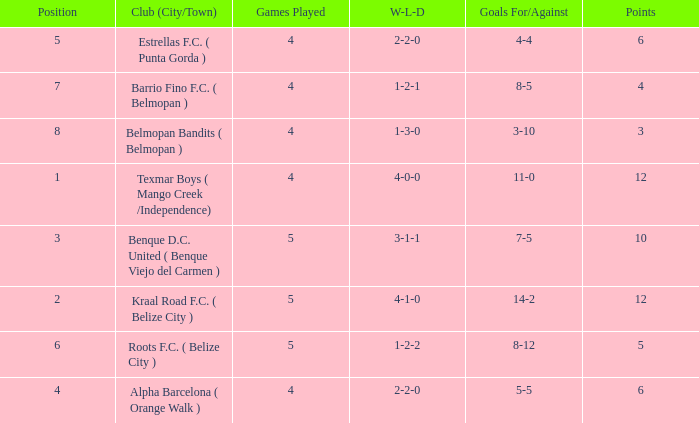What is the minimum games played with goals for/against being 7-5 5.0. 